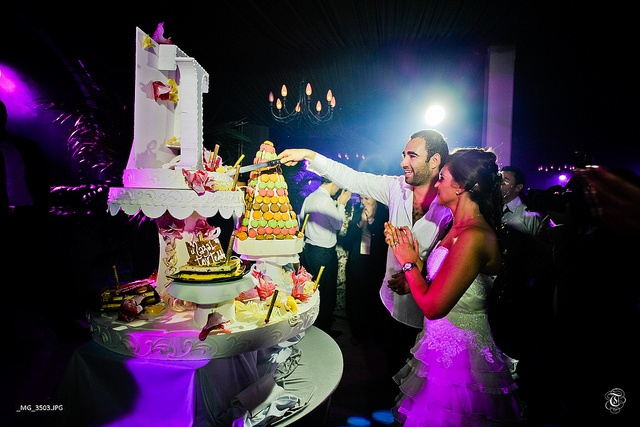Describe the objects in this image and their specific colors. I can see people in black, purple, and brown tones, people in black, lightgray, gray, and darkgray tones, cake in black, darkgray, lightgray, violet, and beige tones, people in black, gray, blue, and darkblue tones, and people in black, beige, purple, and gray tones in this image. 